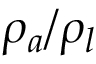Convert formula to latex. <formula><loc_0><loc_0><loc_500><loc_500>\rho _ { a } / \rho _ { l }</formula> 